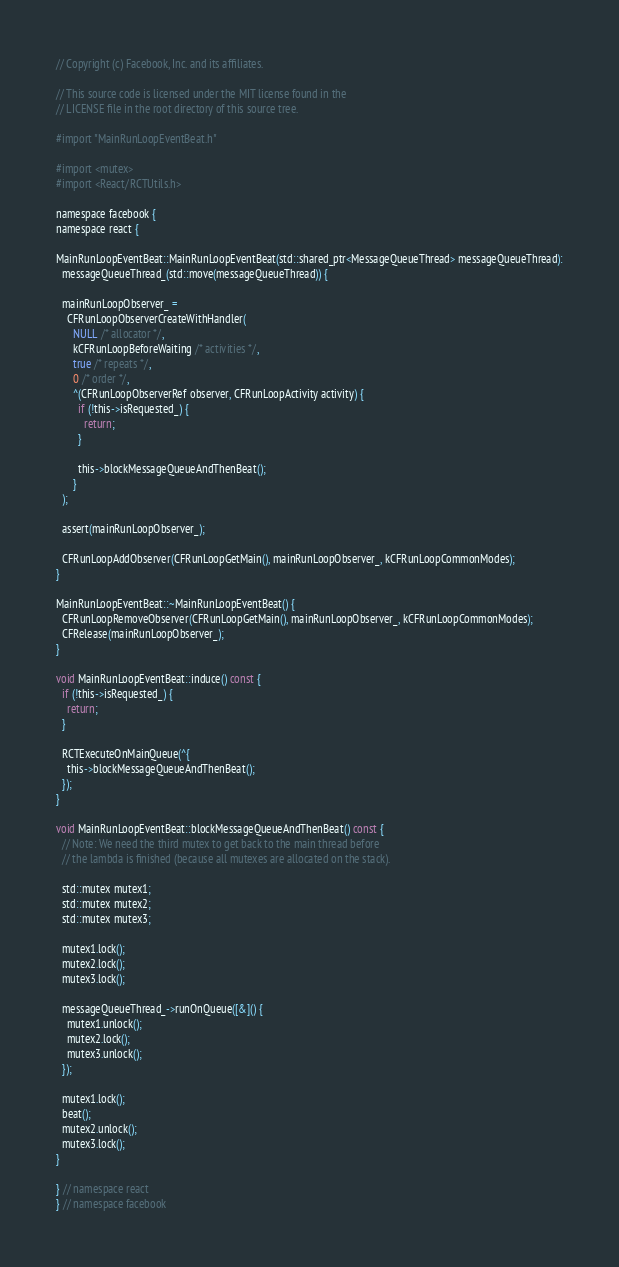<code> <loc_0><loc_0><loc_500><loc_500><_ObjectiveC_>// Copyright (c) Facebook, Inc. and its affiliates.

// This source code is licensed under the MIT license found in the
// LICENSE file in the root directory of this source tree.

#import "MainRunLoopEventBeat.h"

#import <mutex>
#import <React/RCTUtils.h>

namespace facebook {
namespace react {

MainRunLoopEventBeat::MainRunLoopEventBeat(std::shared_ptr<MessageQueueThread> messageQueueThread):
  messageQueueThread_(std::move(messageQueueThread)) {

  mainRunLoopObserver_ =
    CFRunLoopObserverCreateWithHandler(
      NULL /* allocator */,
      kCFRunLoopBeforeWaiting /* activities */,
      true /* repeats */,
      0 /* order */,
      ^(CFRunLoopObserverRef observer, CFRunLoopActivity activity) {
        if (!this->isRequested_) {
          return;
        }

        this->blockMessageQueueAndThenBeat();
      }
  );

  assert(mainRunLoopObserver_);

  CFRunLoopAddObserver(CFRunLoopGetMain(), mainRunLoopObserver_, kCFRunLoopCommonModes);
}

MainRunLoopEventBeat::~MainRunLoopEventBeat() {
  CFRunLoopRemoveObserver(CFRunLoopGetMain(), mainRunLoopObserver_, kCFRunLoopCommonModes);
  CFRelease(mainRunLoopObserver_);
}

void MainRunLoopEventBeat::induce() const {
  if (!this->isRequested_) {
    return;
  }

  RCTExecuteOnMainQueue(^{
    this->blockMessageQueueAndThenBeat();
  });
}

void MainRunLoopEventBeat::blockMessageQueueAndThenBeat() const {
  // Note: We need the third mutex to get back to the main thread before
  // the lambda is finished (because all mutexes are allocated on the stack).

  std::mutex mutex1;
  std::mutex mutex2;
  std::mutex mutex3;

  mutex1.lock();
  mutex2.lock();
  mutex3.lock();

  messageQueueThread_->runOnQueue([&]() {
    mutex1.unlock();
    mutex2.lock();
    mutex3.unlock();
  });

  mutex1.lock();
  beat();
  mutex2.unlock();
  mutex3.lock();
}

} // namespace react
} // namespace facebook
</code> 